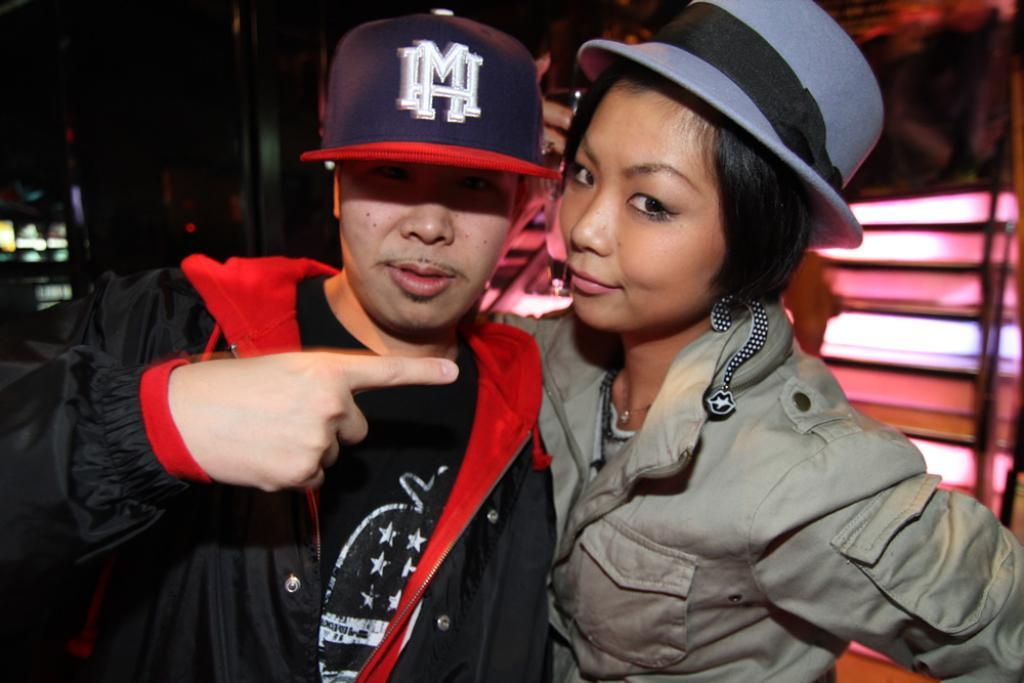How many people are in the image? There are two people in the image, a man and a woman. What are the man and woman wearing? Both the man and woman are wearing clothes. Can you describe the man's headwear? The man is wearing a hat. What expressions do the man and woman have in the image? Both the man and woman are smiling. How would you describe the background of the image? The background of the image is blurred. What can be seen in the image that might provide illumination? There are lights visible in the image. What type of farm animals can be seen in the image? There are no farm animals present in the image. Can you tell me how many buttons the man is pushing in the image? There are no buttons or pushing actions depicted in the image. 